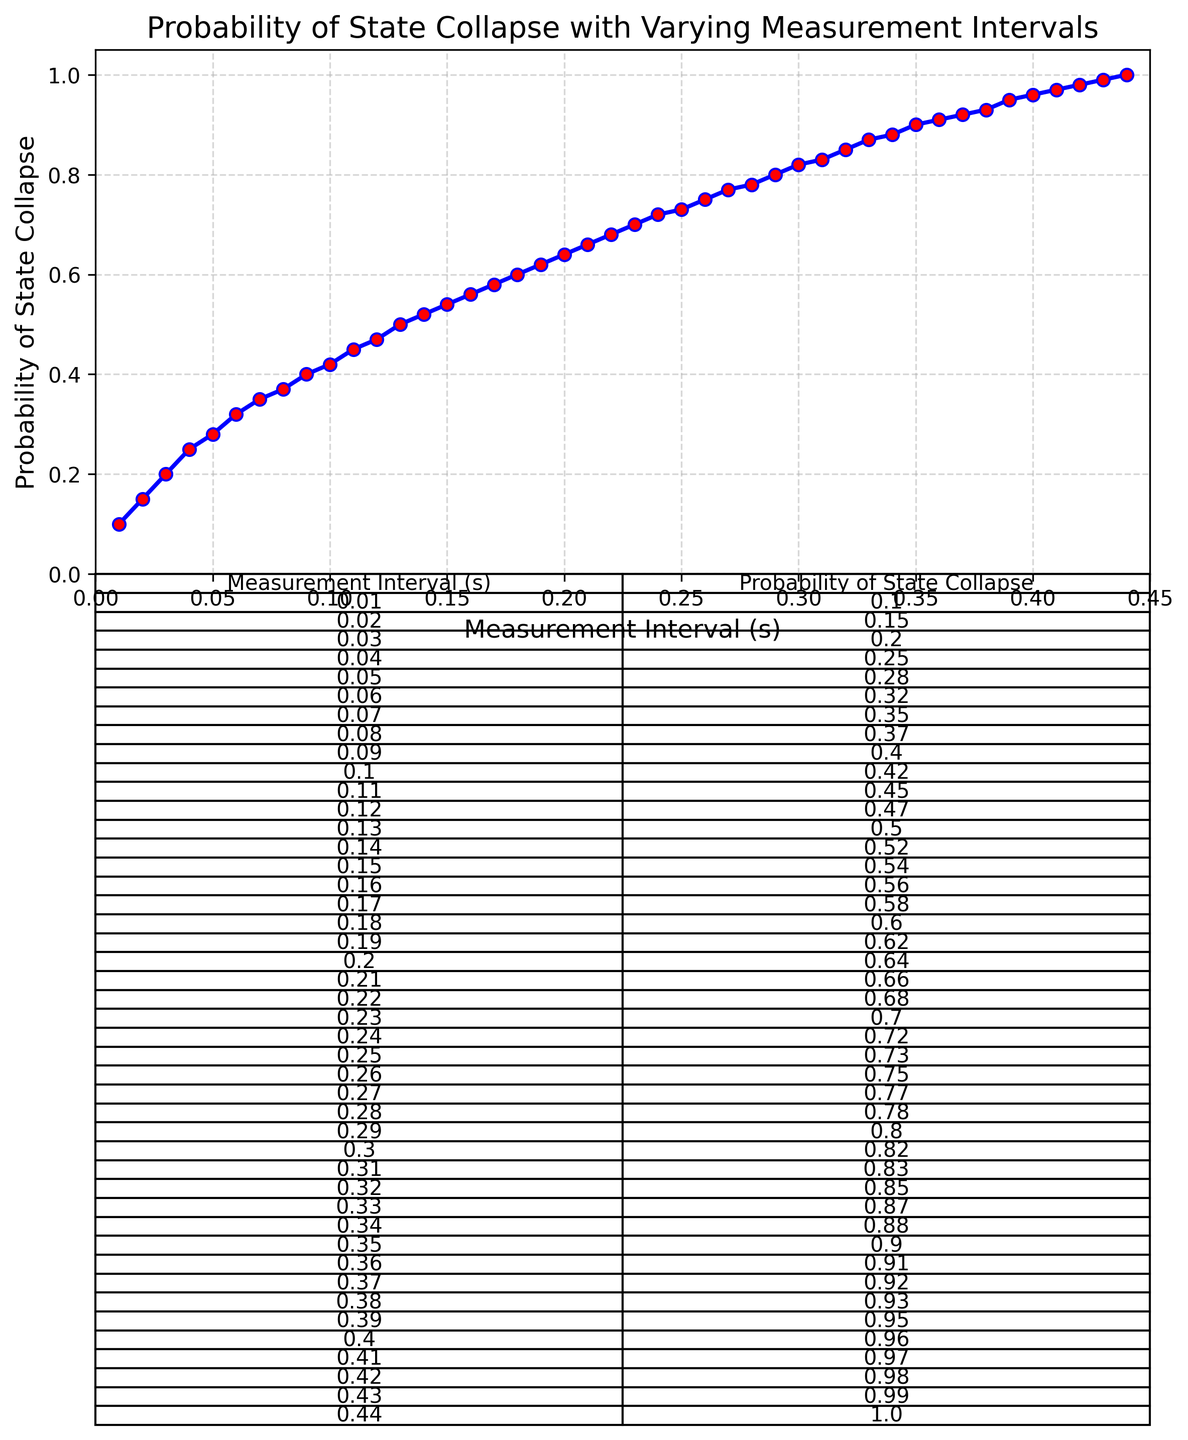What is the probability of state collapse at a measurement interval of 0.2 seconds? At 0.2 seconds, the y-axis value associated with measurement intervals indicates the probability value directly on the chart.
Answer: 0.64 Between which measurement intervals does the probability of state collapse increase the fastest? The slope of the line between points on the graph indicates the rate of change; the steepest part of the curve shows the fastest increase. This is most apparent between 0.01 and 0.02 seconds, and again between 0.39 and 0.41 seconds.
Answer: 0.01 to 0.02 seconds and 0.39 to 0.41 seconds Is there a measurement interval at which the probability of state collapse exactly equals 0.5? Locate 0.5 on the y-axis and see which measurement interval it corresponds to on the x-axis. The line intersects the y-axis at 0.13 seconds.
Answer: 0.13 seconds What is the difference in the probability of state collapse between a measurement interval of 0.1 seconds and 0.3 seconds? Look at the values from the chart at 0.1 seconds (0.42) and 0.3 seconds (0.82), and subtract the former from the latter.
Answer: 0.4 What is the general trend of the probability of state collapse as measurement intervals increase? Observe the overall shape of the plotted line, which shows a continuous ascent from 0 to 1 as the measurement intervals on the x-axis increase.
Answer: Increasing What is the range of the probability of state collapse values shown in the plot? Identify the minimum and maximum values on the y-axis and subtract the minimum from the maximum probability value (0.1 to 1).
Answer: 0.9 At what measurement intervals does the probability of state collapse exceed 0.75? Look along the y-axis to find where the value exceeds 0.75 and trace to the associated x-axis value. This happens after 0.25 seconds.
Answer: After 0.25 seconds What interval of measurements yields a probability of state collapse within the range of 0.4 to 0.6? Find the sections on the y-axis between 0.4 to 0.6 and trace down to corresponding x-axis values. These correspond to the intervals from 0.09 to 0.18 seconds.
Answer: 0.09 to 0.18 seconds How does the plot visually depict the point where the probability of state collapse reaches certainty (1)? The plot visually represents the probability of 1 as the end point of the line segment at 0.44 seconds, where the plotted line reaches its maximum vertical value.
Answer: 0.44 seconds 